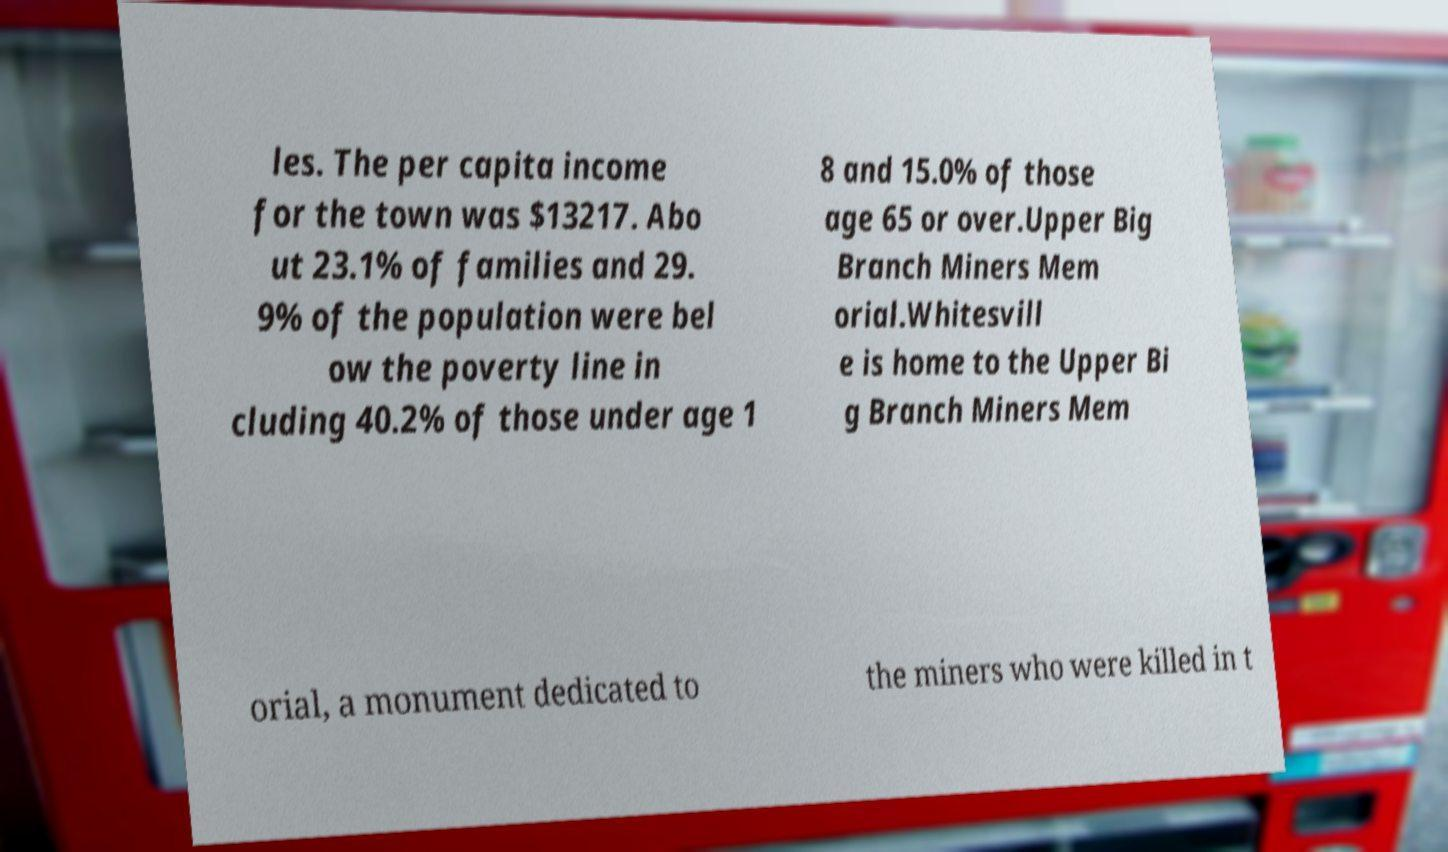Could you extract and type out the text from this image? les. The per capita income for the town was $13217. Abo ut 23.1% of families and 29. 9% of the population were bel ow the poverty line in cluding 40.2% of those under age 1 8 and 15.0% of those age 65 or over.Upper Big Branch Miners Mem orial.Whitesvill e is home to the Upper Bi g Branch Miners Mem orial, a monument dedicated to the miners who were killed in t 